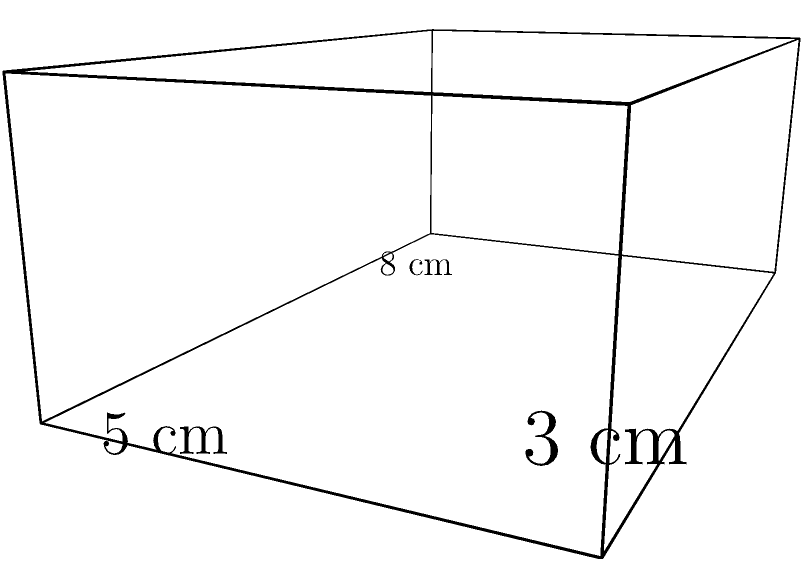A music storage box for Zofia Kilanowicz's rare recordings has dimensions of 8 cm length, 5 cm width, and 3 cm height. Calculate the total surface area of this rectangular prism-shaped box. To calculate the total surface area of a rectangular prism, we need to sum up the areas of all six faces. Let's break it down step-by-step:

1. Identify the dimensions:
   Length (l) = 8 cm
   Width (w) = 5 cm
   Height (h) = 3 cm

2. Calculate the area of each pair of faces:
   a. Front and back faces: $2 * (l * h) = 2 * (8 * 3) = 48$ cm²
   b. Top and bottom faces: $2 * (l * w) = 2 * (8 * 5) = 80$ cm²
   c. Left and right faces: $2 * (w * h) = 2 * (5 * 3) = 30$ cm²

3. Sum up all the areas:
   Total surface area = Front/back + Top/bottom + Left/right
   $= 48 + 80 + 30 = 158$ cm²

Therefore, the total surface area of the music storage box is 158 square centimeters.
Answer: 158 cm² 